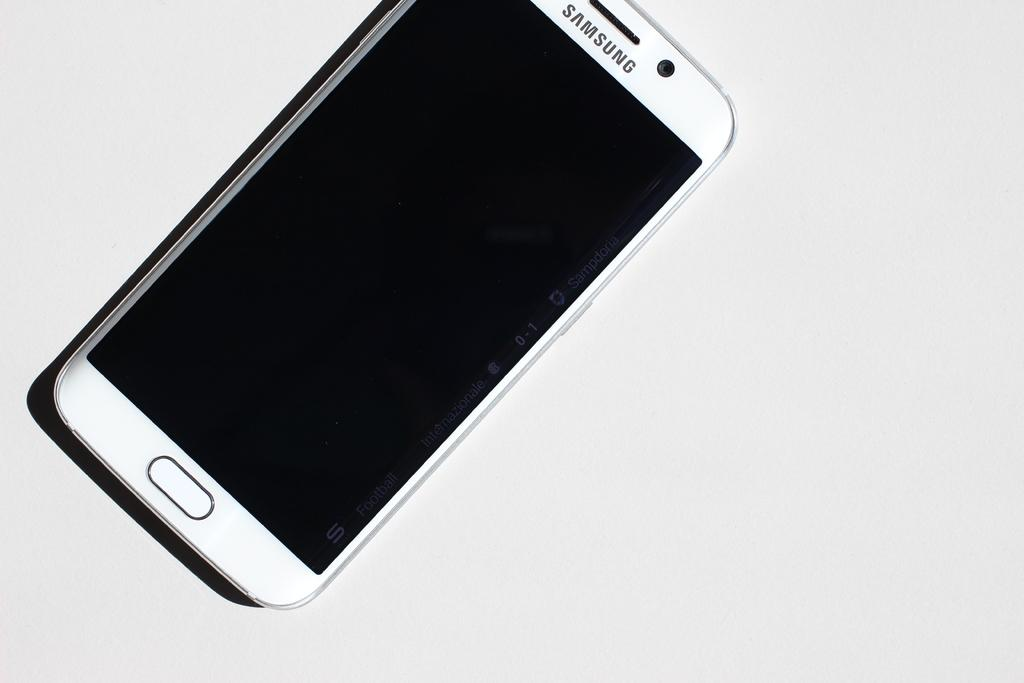<image>
Render a clear and concise summary of the photo. White Samsung cellphone with a black screen and a white background. 